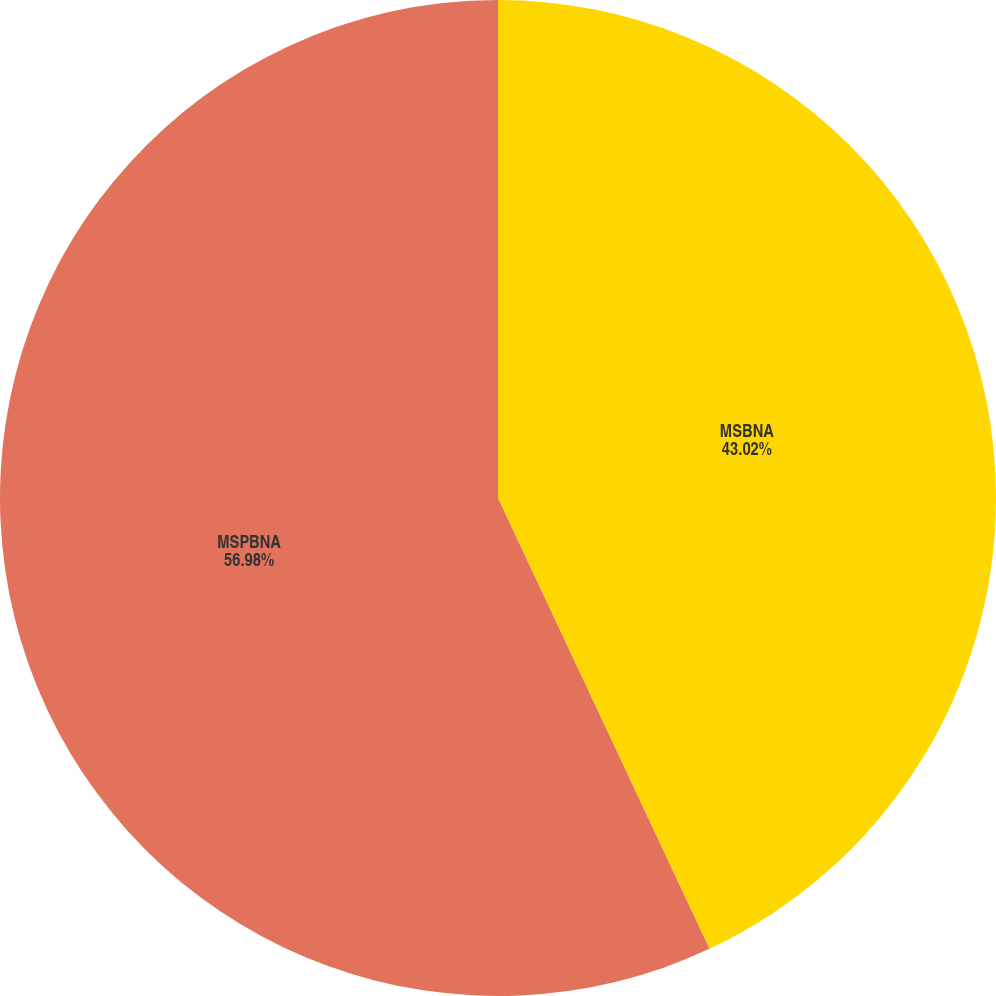<chart> <loc_0><loc_0><loc_500><loc_500><pie_chart><fcel>MSBNA<fcel>MSPBNA<nl><fcel>43.02%<fcel>56.98%<nl></chart> 